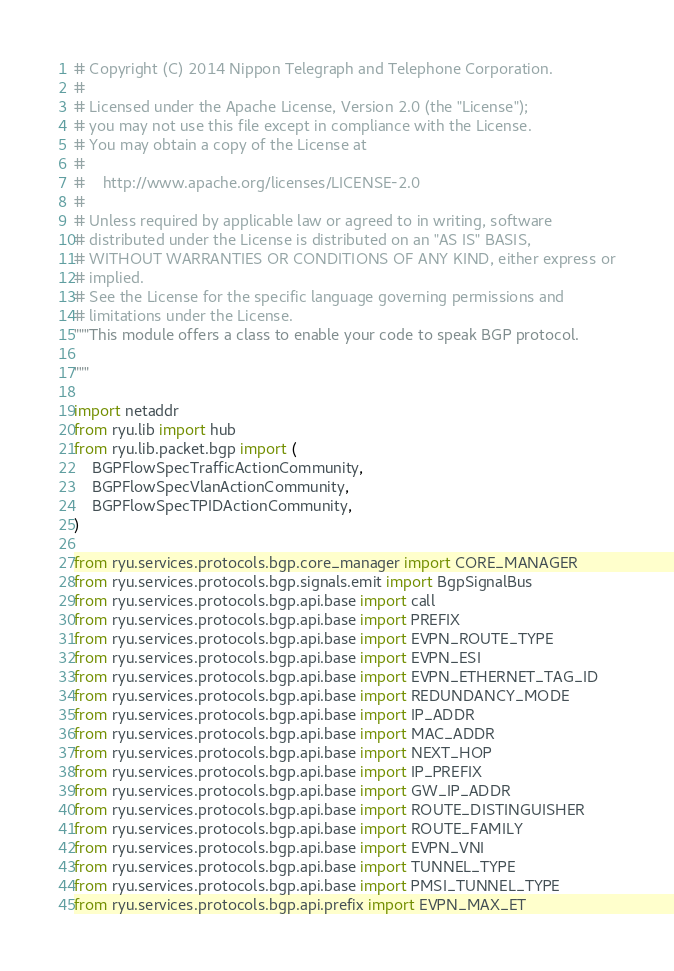Convert code to text. <code><loc_0><loc_0><loc_500><loc_500><_Python_># Copyright (C) 2014 Nippon Telegraph and Telephone Corporation.
#
# Licensed under the Apache License, Version 2.0 (the "License");
# you may not use this file except in compliance with the License.
# You may obtain a copy of the License at
#
#    http://www.apache.org/licenses/LICENSE-2.0
#
# Unless required by applicable law or agreed to in writing, software
# distributed under the License is distributed on an "AS IS" BASIS,
# WITHOUT WARRANTIES OR CONDITIONS OF ANY KIND, either express or
# implied.
# See the License for the specific language governing permissions and
# limitations under the License.
"""This module offers a class to enable your code to speak BGP protocol.

"""

import netaddr
from ryu.lib import hub
from ryu.lib.packet.bgp import (
    BGPFlowSpecTrafficActionCommunity,
    BGPFlowSpecVlanActionCommunity,
    BGPFlowSpecTPIDActionCommunity,
)

from ryu.services.protocols.bgp.core_manager import CORE_MANAGER
from ryu.services.protocols.bgp.signals.emit import BgpSignalBus
from ryu.services.protocols.bgp.api.base import call
from ryu.services.protocols.bgp.api.base import PREFIX
from ryu.services.protocols.bgp.api.base import EVPN_ROUTE_TYPE
from ryu.services.protocols.bgp.api.base import EVPN_ESI
from ryu.services.protocols.bgp.api.base import EVPN_ETHERNET_TAG_ID
from ryu.services.protocols.bgp.api.base import REDUNDANCY_MODE
from ryu.services.protocols.bgp.api.base import IP_ADDR
from ryu.services.protocols.bgp.api.base import MAC_ADDR
from ryu.services.protocols.bgp.api.base import NEXT_HOP
from ryu.services.protocols.bgp.api.base import IP_PREFIX
from ryu.services.protocols.bgp.api.base import GW_IP_ADDR
from ryu.services.protocols.bgp.api.base import ROUTE_DISTINGUISHER
from ryu.services.protocols.bgp.api.base import ROUTE_FAMILY
from ryu.services.protocols.bgp.api.base import EVPN_VNI
from ryu.services.protocols.bgp.api.base import TUNNEL_TYPE
from ryu.services.protocols.bgp.api.base import PMSI_TUNNEL_TYPE
from ryu.services.protocols.bgp.api.prefix import EVPN_MAX_ET</code> 